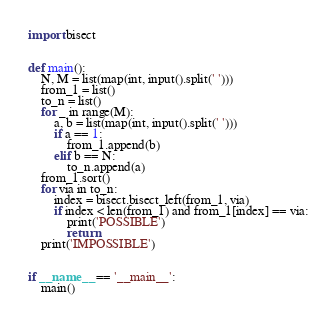<code> <loc_0><loc_0><loc_500><loc_500><_Python_>import bisect


def main():
    N, M = list(map(int, input().split(' ')))
    from_1 = list()
    to_n = list()
    for _ in range(M):
        a, b = list(map(int, input().split(' ')))
        if a == 1:
            from_1.append(b)
        elif b == N:
            to_n.append(a)
    from_1.sort()
    for via in to_n:
        index = bisect.bisect_left(from_1, via)
        if index < len(from_1) and from_1[index] == via:
            print('POSSIBLE')
            return
    print('IMPOSSIBLE')


if __name__ == '__main__':
    main()</code> 